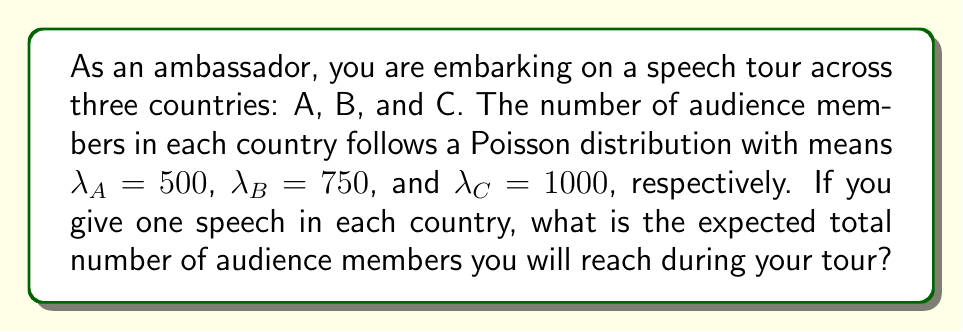Give your solution to this math problem. To solve this problem, we need to understand the properties of Poisson distribution and the concept of linearity of expectation.

1. For a Poisson distribution with mean $\lambda$, the expected value is equal to $\lambda$.

2. The number of audience members in each country is independent of the others.

3. The linearity of expectation states that for independent random variables, the expectation of their sum is equal to the sum of their individual expectations.

Let's define our random variables:
- $X_A$: Number of audience members in country A
- $X_B$: Number of audience members in country B
- $X_C$: Number of audience members in country C

Given:
- $X_A \sim \text{Poisson}(\lambda_A = 500)$
- $X_B \sim \text{Poisson}(\lambda_B = 750)$
- $X_C \sim \text{Poisson}(\lambda_C = 1000)$

The total number of audience members reached is $X_{\text{total}} = X_A + X_B + X_C$

Using the linearity of expectation:

$$E[X_{\text{total}}] = E[X_A + X_B + X_C] = E[X_A] + E[X_B] + E[X_C]$$

Since the expected value of a Poisson distribution is equal to its mean:

$$E[X_A] = \lambda_A = 500$$
$$E[X_B] = \lambda_B = 750$$
$$E[X_C] = \lambda_C = 1000$$

Therefore:

$$E[X_{\text{total}}] = 500 + 750 + 1000 = 2250$$
Answer: The expected total number of audience members reached during the tour is 2250. 